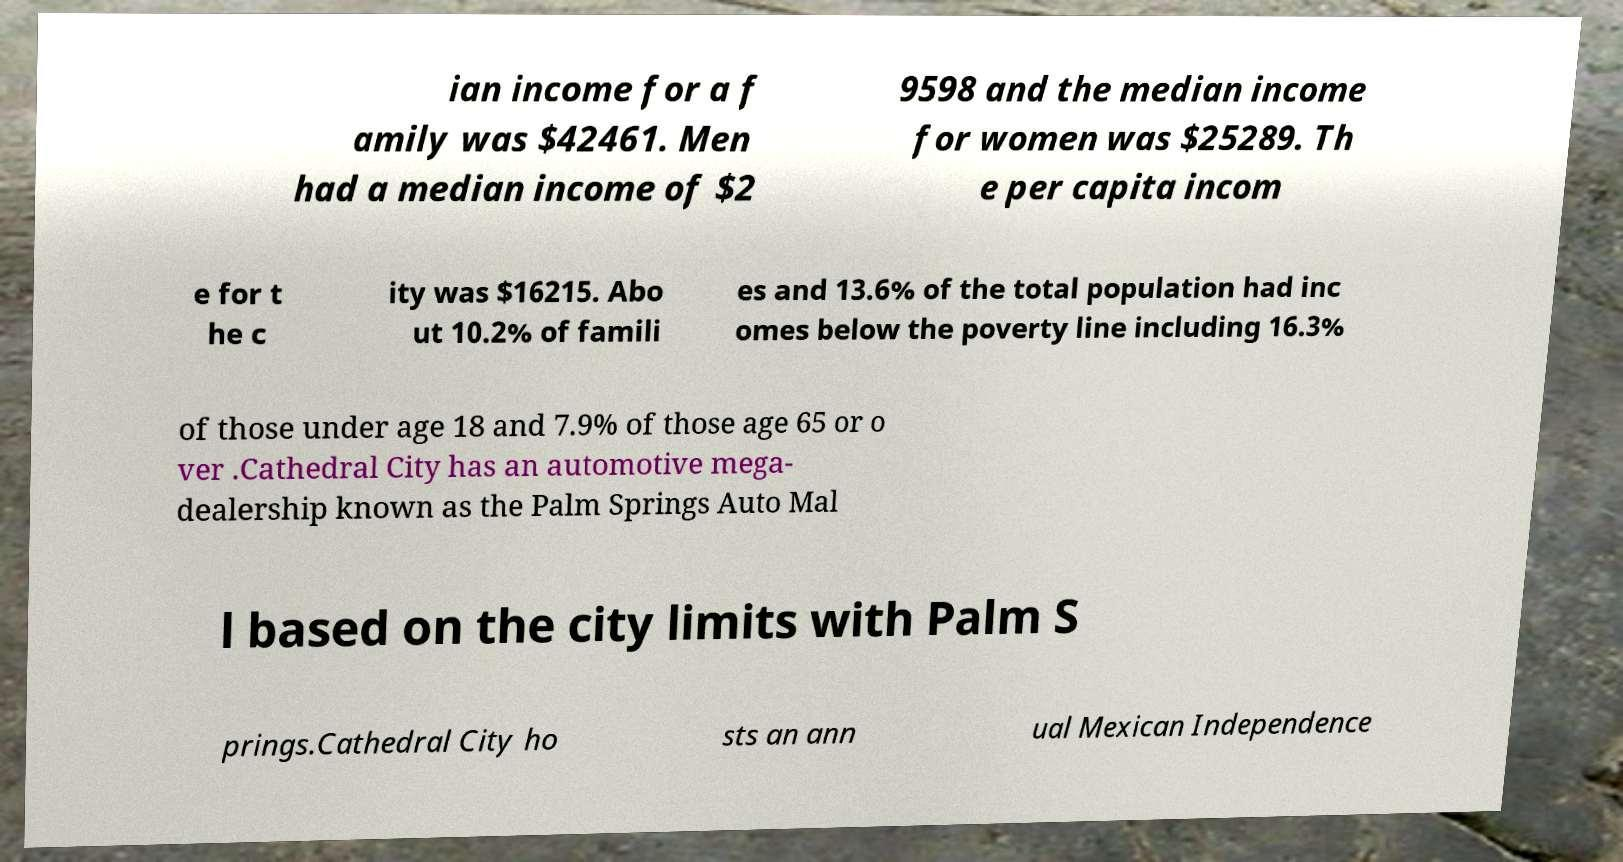What messages or text are displayed in this image? I need them in a readable, typed format. ian income for a f amily was $42461. Men had a median income of $2 9598 and the median income for women was $25289. Th e per capita incom e for t he c ity was $16215. Abo ut 10.2% of famili es and 13.6% of the total population had inc omes below the poverty line including 16.3% of those under age 18 and 7.9% of those age 65 or o ver .Cathedral City has an automotive mega- dealership known as the Palm Springs Auto Mal l based on the city limits with Palm S prings.Cathedral City ho sts an ann ual Mexican Independence 